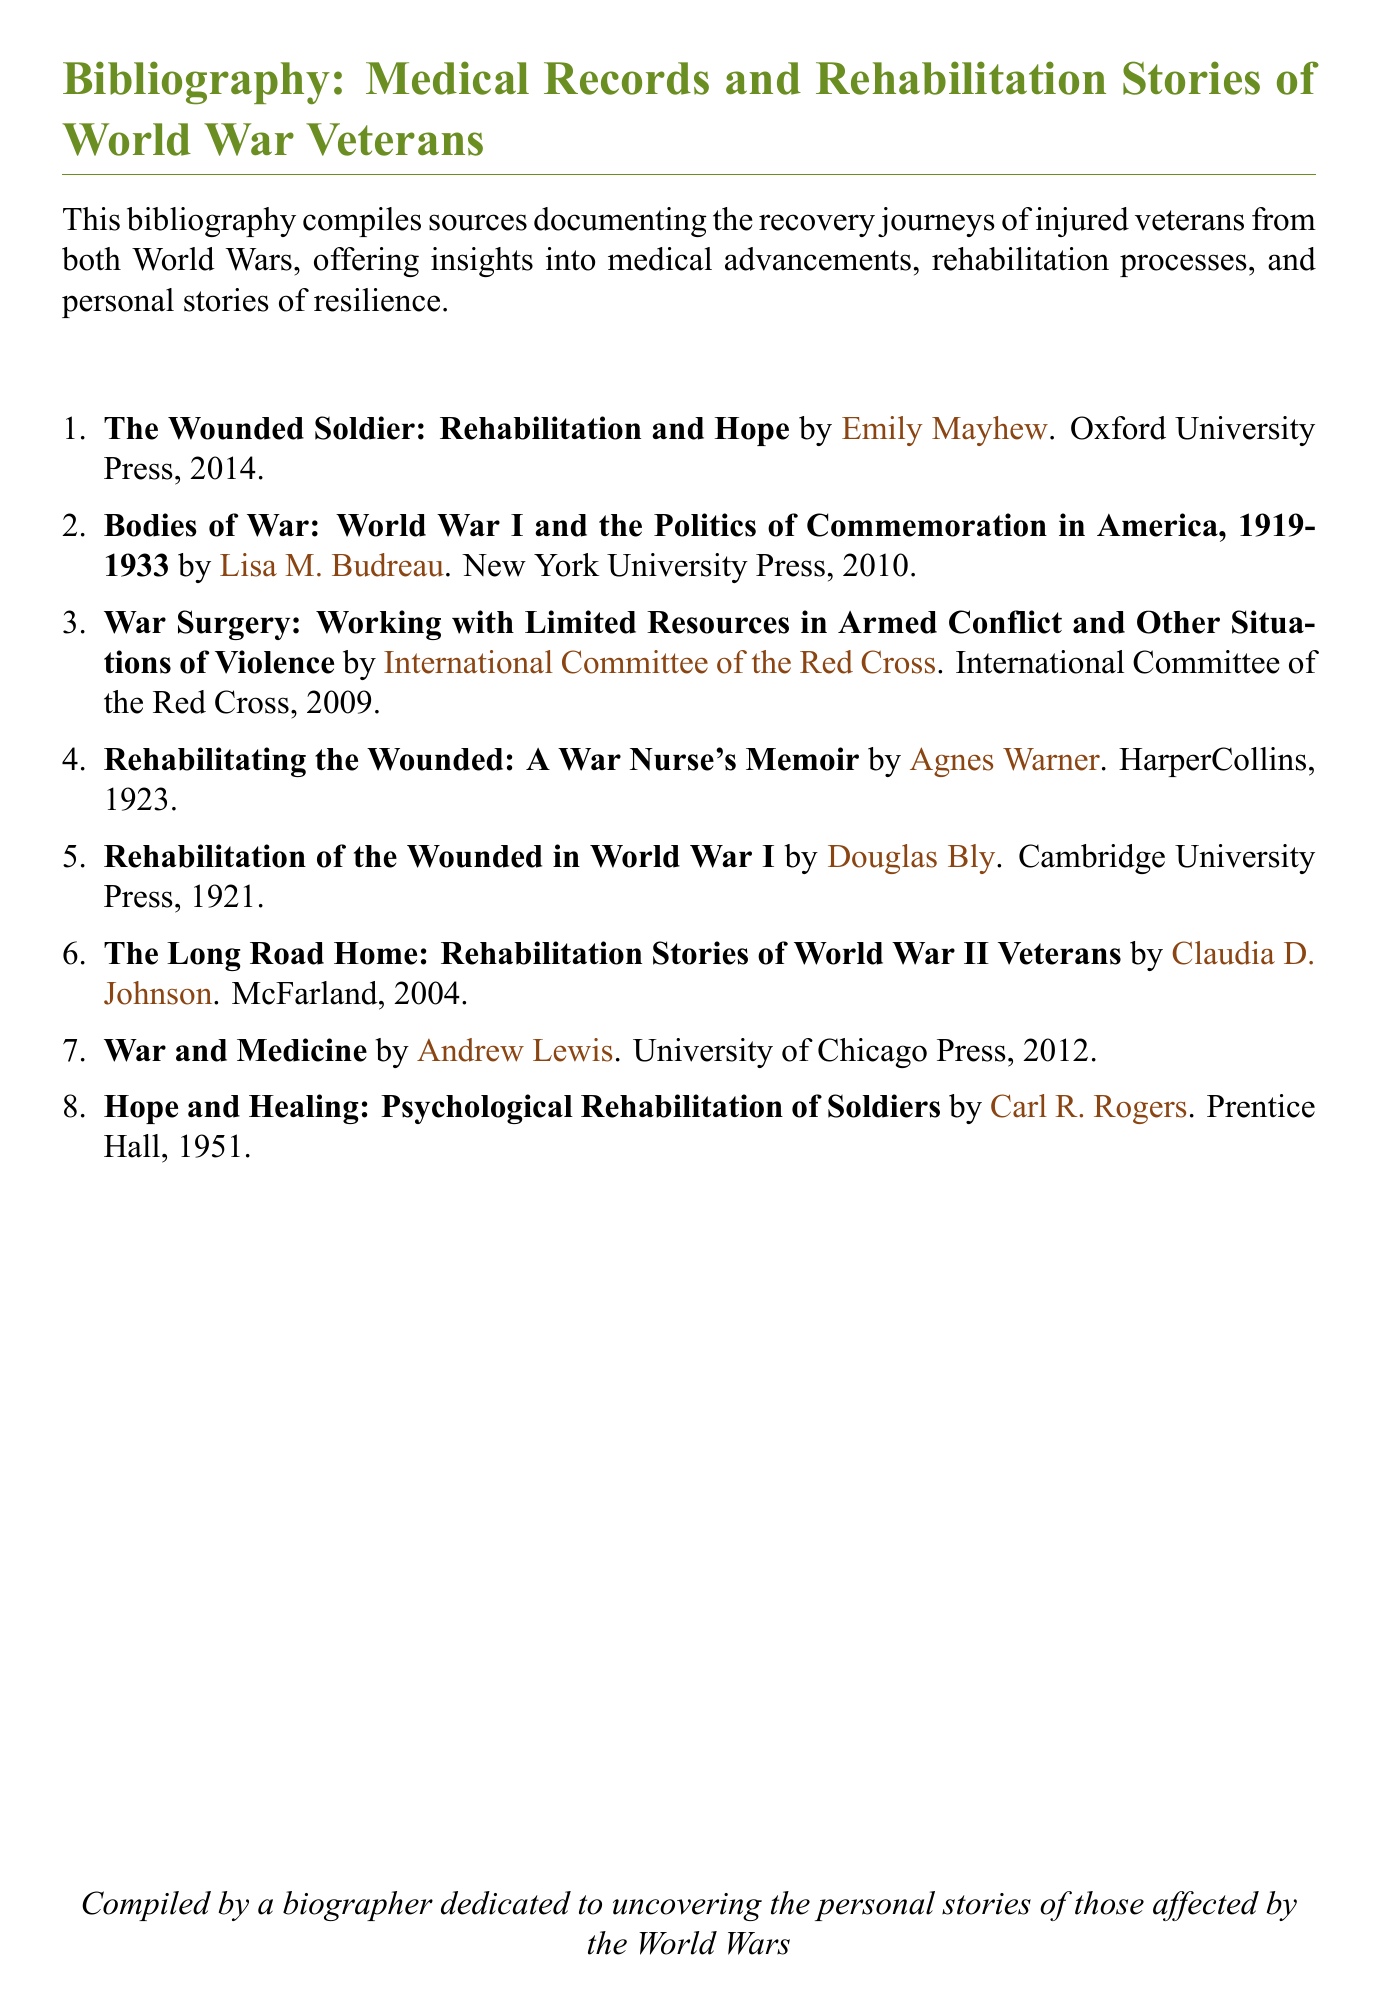What is the title of the first entry? The title of the first entry is the first item listed in the bibliography, which provides the name of the book.
Answer: The Wounded Soldier: Rehabilitation and Hope Who authored "Hope and Healing: Psychological Rehabilitation of Soldiers"? The author is mentioned beside the title in the bibliography, providing a clear authorship attribution.
Answer: Carl R. Rogers In what year was "Rehabilitating the Wounded: A War Nurse's Memoir" published? The year of publication is found at the end of the entry and indicates when the work was released.
Answer: 1923 How many entries are there in the bibliography? The count of entries in the bibliography can be determined by tallying the listed items.
Answer: 8 Which press published "Bodies of War: World War I and the Politics of Commemoration in America, 1919-1933"? The publisher is noted after the author's name in the entry, indicating the organization responsible for the book's publication.
Answer: New York University Press What is the focus of the document? The focus is indicated in the introductory sentence, summarizing the overarching theme of the bibliography.
Answer: Recovery journeys of injured veterans What type of document is this? The nature of the document is evident from the title and content structure, signifying its purpose and format.
Answer: Bibliography What organization published "War Surgery: Working with Limited Resources in Armed Conflict and Other Situations of Violence"? The publisher is stated clearly in the entry, identifying the responsible organization.
Answer: International Committee of the Red Cross 